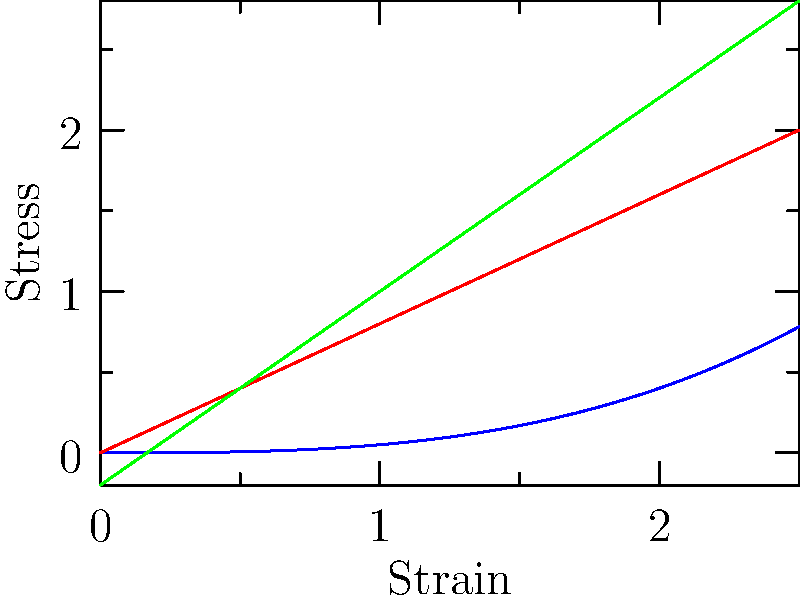As a risk management specialist analyzing investment strategies for a pension fund, you're evaluating a company that manufactures components using different materials. Based on the stress-strain curves shown, which material would likely have the highest toughness and be most suitable for applications requiring energy absorption before failure? To determine which material has the highest toughness, we need to analyze the stress-strain curves for each material:

1. Toughness is represented by the area under the stress-strain curve. It indicates the amount of energy a material can absorb before failure.

2. Material A (blue curve):
   - Shows a non-linear relationship between stress and strain.
   - The curve has a large area underneath it.
   - This indicates high energy absorption capacity.

3. Material B (red curve):
   - Shows a linear relationship between stress and strain.
   - The area under the curve is smaller than Material A.
   - This suggests lower energy absorption capacity compared to Material A.

4. Material C (green curve):
   - Also shows a linear relationship, but with a steeper slope than Material B.
   - The area under the curve is similar to Material B, but less than Material A.

5. Comparing the three materials:
   - Material A has the largest area under its curve, indicating the highest toughness.
   - Materials B and C have smaller areas, suggesting lower toughness.

6. For applications requiring energy absorption before failure:
   - Material A would be the most suitable due to its high toughness.
   - It can absorb more energy through plastic deformation before ultimate failure.

From an investment perspective, a company using Material A for energy-absorbing applications might have a competitive advantage in certain markets, potentially leading to better long-term performance and stability.
Answer: Material A (blue curve) 